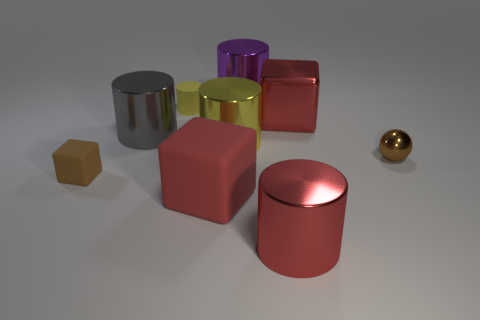Is the tiny rubber block the same color as the tiny shiny ball?
Offer a very short reply. Yes. What number of large objects are purple metal objects or yellow matte spheres?
Provide a short and direct response. 1. There is a red cube that is on the left side of the large cylinder in front of the brown shiny ball on the right side of the big yellow metallic cylinder; what is its material?
Make the answer very short. Rubber. What number of rubber things are purple cubes or cubes?
Ensure brevity in your answer.  2. What number of blue objects are either metal things or large cylinders?
Offer a terse response. 0. Do the small object that is on the right side of the big yellow cylinder and the tiny rubber cube have the same color?
Offer a terse response. Yes. Is the material of the large purple cylinder the same as the big gray object?
Your answer should be very brief. Yes. Are there an equal number of purple things that are in front of the purple object and big yellow metallic objects that are on the right side of the brown metallic sphere?
Keep it short and to the point. Yes. There is a red thing that is the same shape as the purple metallic object; what material is it?
Offer a terse response. Metal. What is the shape of the brown thing that is left of the tiny brown thing that is to the right of the metal object left of the red rubber block?
Your answer should be very brief. Cube. 